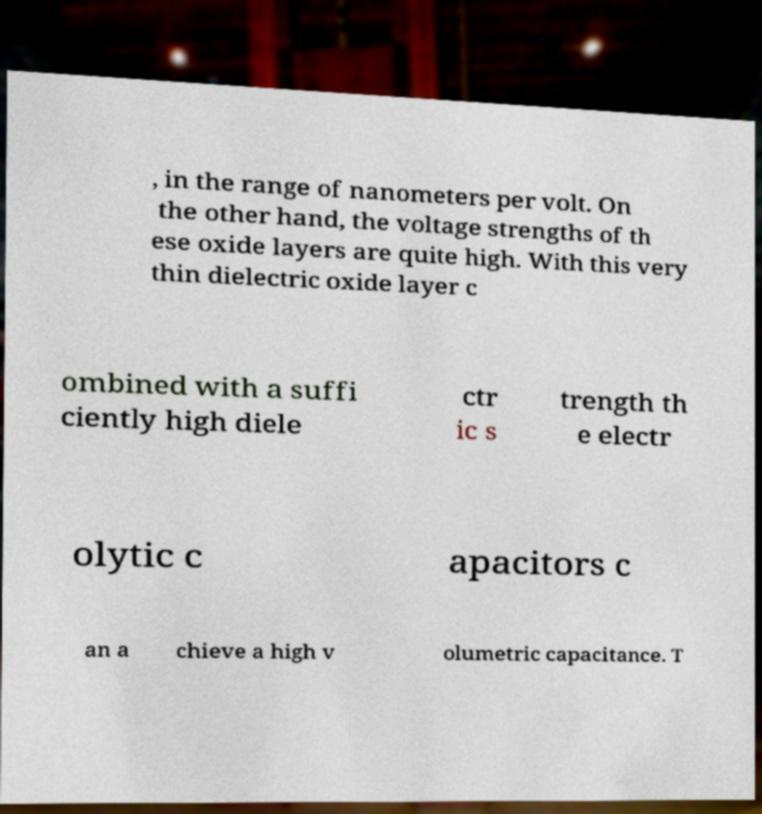Please identify and transcribe the text found in this image. , in the range of nanometers per volt. On the other hand, the voltage strengths of th ese oxide layers are quite high. With this very thin dielectric oxide layer c ombined with a suffi ciently high diele ctr ic s trength th e electr olytic c apacitors c an a chieve a high v olumetric capacitance. T 